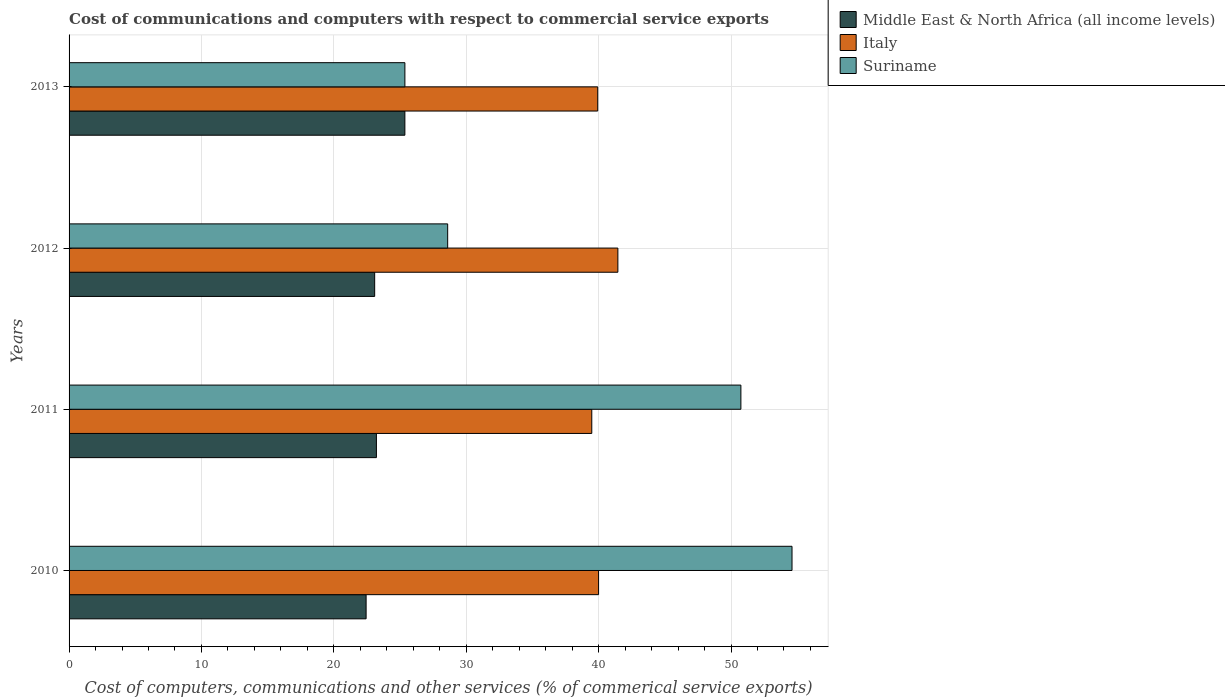How many groups of bars are there?
Your response must be concise. 4. Are the number of bars on each tick of the Y-axis equal?
Provide a succinct answer. Yes. How many bars are there on the 1st tick from the top?
Ensure brevity in your answer.  3. How many bars are there on the 2nd tick from the bottom?
Offer a very short reply. 3. What is the cost of communications and computers in Italy in 2010?
Offer a very short reply. 40. Across all years, what is the maximum cost of communications and computers in Suriname?
Offer a terse response. 54.61. Across all years, what is the minimum cost of communications and computers in Suriname?
Your answer should be compact. 25.37. In which year was the cost of communications and computers in Middle East & North Africa (all income levels) maximum?
Keep it short and to the point. 2013. What is the total cost of communications and computers in Suriname in the graph?
Give a very brief answer. 159.32. What is the difference between the cost of communications and computers in Italy in 2010 and that in 2013?
Your answer should be very brief. 0.06. What is the difference between the cost of communications and computers in Middle East & North Africa (all income levels) in 2010 and the cost of communications and computers in Italy in 2013?
Your answer should be compact. -17.49. What is the average cost of communications and computers in Suriname per year?
Provide a succinct answer. 39.83. In the year 2012, what is the difference between the cost of communications and computers in Italy and cost of communications and computers in Suriname?
Provide a succinct answer. 12.86. What is the ratio of the cost of communications and computers in Middle East & North Africa (all income levels) in 2010 to that in 2011?
Provide a short and direct response. 0.97. Is the difference between the cost of communications and computers in Italy in 2011 and 2012 greater than the difference between the cost of communications and computers in Suriname in 2011 and 2012?
Your response must be concise. No. What is the difference between the highest and the second highest cost of communications and computers in Suriname?
Your answer should be compact. 3.86. What is the difference between the highest and the lowest cost of communications and computers in Middle East & North Africa (all income levels)?
Provide a short and direct response. 2.93. What does the 2nd bar from the top in 2011 represents?
Your answer should be compact. Italy. What does the 3rd bar from the bottom in 2013 represents?
Keep it short and to the point. Suriname. How many bars are there?
Provide a succinct answer. 12. How many years are there in the graph?
Offer a terse response. 4. Does the graph contain grids?
Offer a very short reply. Yes. How many legend labels are there?
Ensure brevity in your answer.  3. How are the legend labels stacked?
Your answer should be compact. Vertical. What is the title of the graph?
Make the answer very short. Cost of communications and computers with respect to commercial service exports. Does "Pacific island small states" appear as one of the legend labels in the graph?
Ensure brevity in your answer.  No. What is the label or title of the X-axis?
Give a very brief answer. Cost of computers, communications and other services (% of commerical service exports). What is the label or title of the Y-axis?
Give a very brief answer. Years. What is the Cost of computers, communications and other services (% of commerical service exports) of Middle East & North Africa (all income levels) in 2010?
Your answer should be compact. 22.44. What is the Cost of computers, communications and other services (% of commerical service exports) of Italy in 2010?
Provide a succinct answer. 40. What is the Cost of computers, communications and other services (% of commerical service exports) of Suriname in 2010?
Your response must be concise. 54.61. What is the Cost of computers, communications and other services (% of commerical service exports) of Middle East & North Africa (all income levels) in 2011?
Provide a succinct answer. 23.21. What is the Cost of computers, communications and other services (% of commerical service exports) in Italy in 2011?
Provide a succinct answer. 39.48. What is the Cost of computers, communications and other services (% of commerical service exports) in Suriname in 2011?
Make the answer very short. 50.75. What is the Cost of computers, communications and other services (% of commerical service exports) in Middle East & North Africa (all income levels) in 2012?
Offer a terse response. 23.08. What is the Cost of computers, communications and other services (% of commerical service exports) in Italy in 2012?
Your answer should be compact. 41.45. What is the Cost of computers, communications and other services (% of commerical service exports) in Suriname in 2012?
Keep it short and to the point. 28.6. What is the Cost of computers, communications and other services (% of commerical service exports) in Middle East & North Africa (all income levels) in 2013?
Your answer should be very brief. 25.36. What is the Cost of computers, communications and other services (% of commerical service exports) in Italy in 2013?
Ensure brevity in your answer.  39.93. What is the Cost of computers, communications and other services (% of commerical service exports) in Suriname in 2013?
Ensure brevity in your answer.  25.37. Across all years, what is the maximum Cost of computers, communications and other services (% of commerical service exports) of Middle East & North Africa (all income levels)?
Your response must be concise. 25.36. Across all years, what is the maximum Cost of computers, communications and other services (% of commerical service exports) in Italy?
Provide a short and direct response. 41.45. Across all years, what is the maximum Cost of computers, communications and other services (% of commerical service exports) of Suriname?
Provide a short and direct response. 54.61. Across all years, what is the minimum Cost of computers, communications and other services (% of commerical service exports) of Middle East & North Africa (all income levels)?
Provide a short and direct response. 22.44. Across all years, what is the minimum Cost of computers, communications and other services (% of commerical service exports) in Italy?
Keep it short and to the point. 39.48. Across all years, what is the minimum Cost of computers, communications and other services (% of commerical service exports) in Suriname?
Provide a short and direct response. 25.37. What is the total Cost of computers, communications and other services (% of commerical service exports) of Middle East & North Africa (all income levels) in the graph?
Provide a short and direct response. 94.1. What is the total Cost of computers, communications and other services (% of commerical service exports) in Italy in the graph?
Make the answer very short. 160.86. What is the total Cost of computers, communications and other services (% of commerical service exports) of Suriname in the graph?
Offer a very short reply. 159.32. What is the difference between the Cost of computers, communications and other services (% of commerical service exports) in Middle East & North Africa (all income levels) in 2010 and that in 2011?
Provide a short and direct response. -0.78. What is the difference between the Cost of computers, communications and other services (% of commerical service exports) in Italy in 2010 and that in 2011?
Your answer should be compact. 0.51. What is the difference between the Cost of computers, communications and other services (% of commerical service exports) in Suriname in 2010 and that in 2011?
Your answer should be very brief. 3.86. What is the difference between the Cost of computers, communications and other services (% of commerical service exports) of Middle East & North Africa (all income levels) in 2010 and that in 2012?
Provide a succinct answer. -0.65. What is the difference between the Cost of computers, communications and other services (% of commerical service exports) in Italy in 2010 and that in 2012?
Offer a terse response. -1.46. What is the difference between the Cost of computers, communications and other services (% of commerical service exports) in Suriname in 2010 and that in 2012?
Ensure brevity in your answer.  26.01. What is the difference between the Cost of computers, communications and other services (% of commerical service exports) in Middle East & North Africa (all income levels) in 2010 and that in 2013?
Your answer should be compact. -2.93. What is the difference between the Cost of computers, communications and other services (% of commerical service exports) of Italy in 2010 and that in 2013?
Provide a short and direct response. 0.06. What is the difference between the Cost of computers, communications and other services (% of commerical service exports) of Suriname in 2010 and that in 2013?
Keep it short and to the point. 29.24. What is the difference between the Cost of computers, communications and other services (% of commerical service exports) of Middle East & North Africa (all income levels) in 2011 and that in 2012?
Make the answer very short. 0.13. What is the difference between the Cost of computers, communications and other services (% of commerical service exports) in Italy in 2011 and that in 2012?
Ensure brevity in your answer.  -1.97. What is the difference between the Cost of computers, communications and other services (% of commerical service exports) in Suriname in 2011 and that in 2012?
Offer a very short reply. 22.15. What is the difference between the Cost of computers, communications and other services (% of commerical service exports) of Middle East & North Africa (all income levels) in 2011 and that in 2013?
Provide a short and direct response. -2.15. What is the difference between the Cost of computers, communications and other services (% of commerical service exports) in Italy in 2011 and that in 2013?
Your answer should be compact. -0.45. What is the difference between the Cost of computers, communications and other services (% of commerical service exports) of Suriname in 2011 and that in 2013?
Your answer should be very brief. 25.38. What is the difference between the Cost of computers, communications and other services (% of commerical service exports) in Middle East & North Africa (all income levels) in 2012 and that in 2013?
Make the answer very short. -2.28. What is the difference between the Cost of computers, communications and other services (% of commerical service exports) of Italy in 2012 and that in 2013?
Offer a terse response. 1.52. What is the difference between the Cost of computers, communications and other services (% of commerical service exports) of Suriname in 2012 and that in 2013?
Provide a short and direct response. 3.23. What is the difference between the Cost of computers, communications and other services (% of commerical service exports) in Middle East & North Africa (all income levels) in 2010 and the Cost of computers, communications and other services (% of commerical service exports) in Italy in 2011?
Your response must be concise. -17.05. What is the difference between the Cost of computers, communications and other services (% of commerical service exports) of Middle East & North Africa (all income levels) in 2010 and the Cost of computers, communications and other services (% of commerical service exports) of Suriname in 2011?
Provide a short and direct response. -28.31. What is the difference between the Cost of computers, communications and other services (% of commerical service exports) of Italy in 2010 and the Cost of computers, communications and other services (% of commerical service exports) of Suriname in 2011?
Make the answer very short. -10.75. What is the difference between the Cost of computers, communications and other services (% of commerical service exports) in Middle East & North Africa (all income levels) in 2010 and the Cost of computers, communications and other services (% of commerical service exports) in Italy in 2012?
Make the answer very short. -19.02. What is the difference between the Cost of computers, communications and other services (% of commerical service exports) in Middle East & North Africa (all income levels) in 2010 and the Cost of computers, communications and other services (% of commerical service exports) in Suriname in 2012?
Ensure brevity in your answer.  -6.16. What is the difference between the Cost of computers, communications and other services (% of commerical service exports) of Italy in 2010 and the Cost of computers, communications and other services (% of commerical service exports) of Suriname in 2012?
Your response must be concise. 11.4. What is the difference between the Cost of computers, communications and other services (% of commerical service exports) of Middle East & North Africa (all income levels) in 2010 and the Cost of computers, communications and other services (% of commerical service exports) of Italy in 2013?
Offer a terse response. -17.5. What is the difference between the Cost of computers, communications and other services (% of commerical service exports) of Middle East & North Africa (all income levels) in 2010 and the Cost of computers, communications and other services (% of commerical service exports) of Suriname in 2013?
Offer a terse response. -2.93. What is the difference between the Cost of computers, communications and other services (% of commerical service exports) of Italy in 2010 and the Cost of computers, communications and other services (% of commerical service exports) of Suriname in 2013?
Make the answer very short. 14.63. What is the difference between the Cost of computers, communications and other services (% of commerical service exports) of Middle East & North Africa (all income levels) in 2011 and the Cost of computers, communications and other services (% of commerical service exports) of Italy in 2012?
Make the answer very short. -18.24. What is the difference between the Cost of computers, communications and other services (% of commerical service exports) of Middle East & North Africa (all income levels) in 2011 and the Cost of computers, communications and other services (% of commerical service exports) of Suriname in 2012?
Give a very brief answer. -5.38. What is the difference between the Cost of computers, communications and other services (% of commerical service exports) in Italy in 2011 and the Cost of computers, communications and other services (% of commerical service exports) in Suriname in 2012?
Provide a short and direct response. 10.89. What is the difference between the Cost of computers, communications and other services (% of commerical service exports) of Middle East & North Africa (all income levels) in 2011 and the Cost of computers, communications and other services (% of commerical service exports) of Italy in 2013?
Provide a succinct answer. -16.72. What is the difference between the Cost of computers, communications and other services (% of commerical service exports) of Middle East & North Africa (all income levels) in 2011 and the Cost of computers, communications and other services (% of commerical service exports) of Suriname in 2013?
Make the answer very short. -2.15. What is the difference between the Cost of computers, communications and other services (% of commerical service exports) of Italy in 2011 and the Cost of computers, communications and other services (% of commerical service exports) of Suriname in 2013?
Make the answer very short. 14.12. What is the difference between the Cost of computers, communications and other services (% of commerical service exports) in Middle East & North Africa (all income levels) in 2012 and the Cost of computers, communications and other services (% of commerical service exports) in Italy in 2013?
Your answer should be compact. -16.85. What is the difference between the Cost of computers, communications and other services (% of commerical service exports) in Middle East & North Africa (all income levels) in 2012 and the Cost of computers, communications and other services (% of commerical service exports) in Suriname in 2013?
Offer a terse response. -2.28. What is the difference between the Cost of computers, communications and other services (% of commerical service exports) in Italy in 2012 and the Cost of computers, communications and other services (% of commerical service exports) in Suriname in 2013?
Offer a terse response. 16.09. What is the average Cost of computers, communications and other services (% of commerical service exports) in Middle East & North Africa (all income levels) per year?
Provide a short and direct response. 23.52. What is the average Cost of computers, communications and other services (% of commerical service exports) in Italy per year?
Your response must be concise. 40.22. What is the average Cost of computers, communications and other services (% of commerical service exports) of Suriname per year?
Your response must be concise. 39.83. In the year 2010, what is the difference between the Cost of computers, communications and other services (% of commerical service exports) of Middle East & North Africa (all income levels) and Cost of computers, communications and other services (% of commerical service exports) of Italy?
Offer a terse response. -17.56. In the year 2010, what is the difference between the Cost of computers, communications and other services (% of commerical service exports) of Middle East & North Africa (all income levels) and Cost of computers, communications and other services (% of commerical service exports) of Suriname?
Make the answer very short. -32.17. In the year 2010, what is the difference between the Cost of computers, communications and other services (% of commerical service exports) in Italy and Cost of computers, communications and other services (% of commerical service exports) in Suriname?
Your answer should be very brief. -14.61. In the year 2011, what is the difference between the Cost of computers, communications and other services (% of commerical service exports) of Middle East & North Africa (all income levels) and Cost of computers, communications and other services (% of commerical service exports) of Italy?
Offer a very short reply. -16.27. In the year 2011, what is the difference between the Cost of computers, communications and other services (% of commerical service exports) in Middle East & North Africa (all income levels) and Cost of computers, communications and other services (% of commerical service exports) in Suriname?
Provide a short and direct response. -27.53. In the year 2011, what is the difference between the Cost of computers, communications and other services (% of commerical service exports) of Italy and Cost of computers, communications and other services (% of commerical service exports) of Suriname?
Provide a succinct answer. -11.26. In the year 2012, what is the difference between the Cost of computers, communications and other services (% of commerical service exports) of Middle East & North Africa (all income levels) and Cost of computers, communications and other services (% of commerical service exports) of Italy?
Your response must be concise. -18.37. In the year 2012, what is the difference between the Cost of computers, communications and other services (% of commerical service exports) in Middle East & North Africa (all income levels) and Cost of computers, communications and other services (% of commerical service exports) in Suriname?
Make the answer very short. -5.51. In the year 2012, what is the difference between the Cost of computers, communications and other services (% of commerical service exports) in Italy and Cost of computers, communications and other services (% of commerical service exports) in Suriname?
Give a very brief answer. 12.86. In the year 2013, what is the difference between the Cost of computers, communications and other services (% of commerical service exports) in Middle East & North Africa (all income levels) and Cost of computers, communications and other services (% of commerical service exports) in Italy?
Provide a short and direct response. -14.57. In the year 2013, what is the difference between the Cost of computers, communications and other services (% of commerical service exports) of Middle East & North Africa (all income levels) and Cost of computers, communications and other services (% of commerical service exports) of Suriname?
Offer a very short reply. -0. In the year 2013, what is the difference between the Cost of computers, communications and other services (% of commerical service exports) in Italy and Cost of computers, communications and other services (% of commerical service exports) in Suriname?
Keep it short and to the point. 14.56. What is the ratio of the Cost of computers, communications and other services (% of commerical service exports) of Middle East & North Africa (all income levels) in 2010 to that in 2011?
Keep it short and to the point. 0.97. What is the ratio of the Cost of computers, communications and other services (% of commerical service exports) of Italy in 2010 to that in 2011?
Provide a short and direct response. 1.01. What is the ratio of the Cost of computers, communications and other services (% of commerical service exports) in Suriname in 2010 to that in 2011?
Your answer should be compact. 1.08. What is the ratio of the Cost of computers, communications and other services (% of commerical service exports) of Italy in 2010 to that in 2012?
Ensure brevity in your answer.  0.96. What is the ratio of the Cost of computers, communications and other services (% of commerical service exports) in Suriname in 2010 to that in 2012?
Make the answer very short. 1.91. What is the ratio of the Cost of computers, communications and other services (% of commerical service exports) in Middle East & North Africa (all income levels) in 2010 to that in 2013?
Your response must be concise. 0.88. What is the ratio of the Cost of computers, communications and other services (% of commerical service exports) in Suriname in 2010 to that in 2013?
Make the answer very short. 2.15. What is the ratio of the Cost of computers, communications and other services (% of commerical service exports) in Italy in 2011 to that in 2012?
Keep it short and to the point. 0.95. What is the ratio of the Cost of computers, communications and other services (% of commerical service exports) in Suriname in 2011 to that in 2012?
Provide a succinct answer. 1.77. What is the ratio of the Cost of computers, communications and other services (% of commerical service exports) in Middle East & North Africa (all income levels) in 2011 to that in 2013?
Provide a short and direct response. 0.92. What is the ratio of the Cost of computers, communications and other services (% of commerical service exports) of Suriname in 2011 to that in 2013?
Your answer should be compact. 2. What is the ratio of the Cost of computers, communications and other services (% of commerical service exports) in Middle East & North Africa (all income levels) in 2012 to that in 2013?
Ensure brevity in your answer.  0.91. What is the ratio of the Cost of computers, communications and other services (% of commerical service exports) in Italy in 2012 to that in 2013?
Your response must be concise. 1.04. What is the ratio of the Cost of computers, communications and other services (% of commerical service exports) of Suriname in 2012 to that in 2013?
Offer a terse response. 1.13. What is the difference between the highest and the second highest Cost of computers, communications and other services (% of commerical service exports) in Middle East & North Africa (all income levels)?
Ensure brevity in your answer.  2.15. What is the difference between the highest and the second highest Cost of computers, communications and other services (% of commerical service exports) in Italy?
Make the answer very short. 1.46. What is the difference between the highest and the second highest Cost of computers, communications and other services (% of commerical service exports) in Suriname?
Offer a terse response. 3.86. What is the difference between the highest and the lowest Cost of computers, communications and other services (% of commerical service exports) of Middle East & North Africa (all income levels)?
Provide a short and direct response. 2.93. What is the difference between the highest and the lowest Cost of computers, communications and other services (% of commerical service exports) in Italy?
Give a very brief answer. 1.97. What is the difference between the highest and the lowest Cost of computers, communications and other services (% of commerical service exports) of Suriname?
Your answer should be very brief. 29.24. 